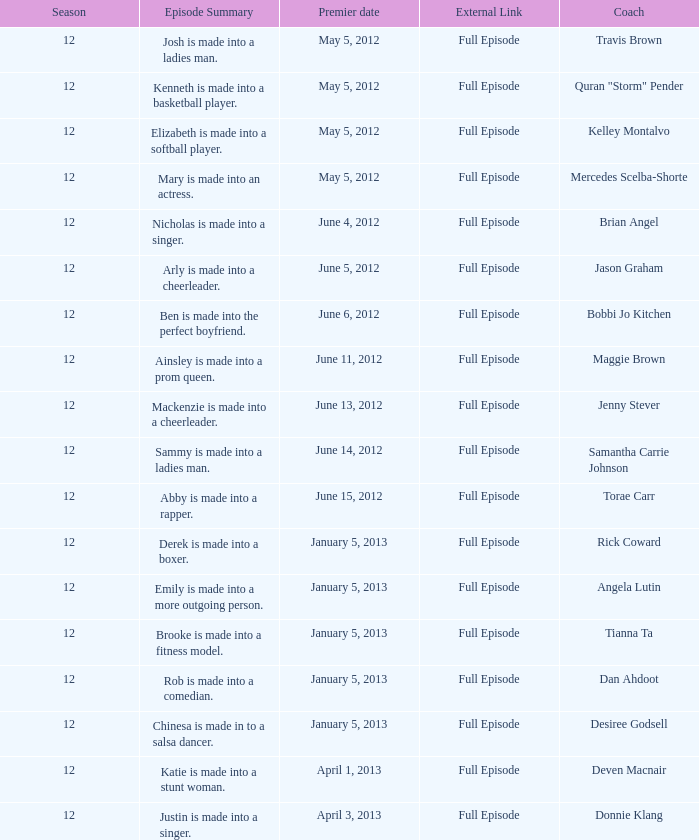Provide the episode description for travis brown. Josh is made into a ladies man. Parse the full table. {'header': ['Season', 'Episode Summary', 'Premier date', 'External Link', 'Coach'], 'rows': [['12', 'Josh is made into a ladies man.', 'May 5, 2012', 'Full Episode', 'Travis Brown'], ['12', 'Kenneth is made into a basketball player.', 'May 5, 2012', 'Full Episode', 'Quran "Storm" Pender'], ['12', 'Elizabeth is made into a softball player.', 'May 5, 2012', 'Full Episode', 'Kelley Montalvo'], ['12', 'Mary is made into an actress.', 'May 5, 2012', 'Full Episode', 'Mercedes Scelba-Shorte'], ['12', 'Nicholas is made into a singer.', 'June 4, 2012', 'Full Episode', 'Brian Angel'], ['12', 'Arly is made into a cheerleader.', 'June 5, 2012', 'Full Episode', 'Jason Graham'], ['12', 'Ben is made into the perfect boyfriend.', 'June 6, 2012', 'Full Episode', 'Bobbi Jo Kitchen'], ['12', 'Ainsley is made into a prom queen.', 'June 11, 2012', 'Full Episode', 'Maggie Brown'], ['12', 'Mackenzie is made into a cheerleader.', 'June 13, 2012', 'Full Episode', 'Jenny Stever'], ['12', 'Sammy is made into a ladies man.', 'June 14, 2012', 'Full Episode', 'Samantha Carrie Johnson'], ['12', 'Abby is made into a rapper.', 'June 15, 2012', 'Full Episode', 'Torae Carr'], ['12', 'Derek is made into a boxer.', 'January 5, 2013', 'Full Episode', 'Rick Coward'], ['12', 'Emily is made into a more outgoing person.', 'January 5, 2013', 'Full Episode', 'Angela Lutin'], ['12', 'Brooke is made into a fitness model.', 'January 5, 2013', 'Full Episode', 'Tianna Ta'], ['12', 'Rob is made into a comedian.', 'January 5, 2013', 'Full Episode', 'Dan Ahdoot'], ['12', 'Chinesa is made in to a salsa dancer.', 'January 5, 2013', 'Full Episode', 'Desiree Godsell'], ['12', 'Katie is made into a stunt woman.', 'April 1, 2013', 'Full Episode', 'Deven Macnair'], ['12', 'Justin is made into a singer.', 'April 3, 2013', 'Full Episode', 'Donnie Klang']]} 